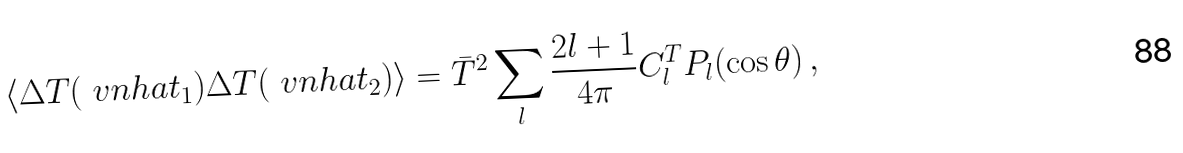Convert formula to latex. <formula><loc_0><loc_0><loc_500><loc_500>\langle \Delta T ( \ v n h a t _ { 1 } ) \Delta T ( \ v n h a t _ { 2 } ) \rangle = \bar { T } ^ { 2 } \sum _ { l } \frac { 2 l + 1 } { 4 \pi } C _ { l } ^ { T } P _ { l } ( \cos \theta ) \, ,</formula> 